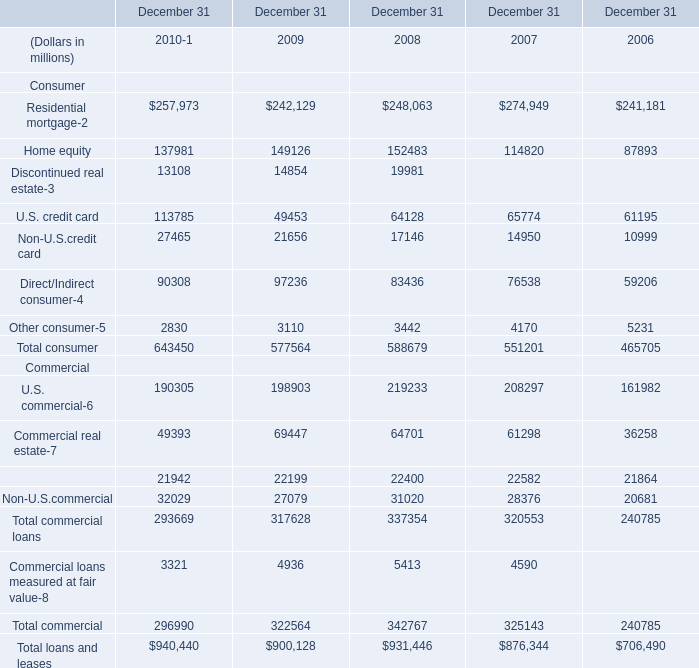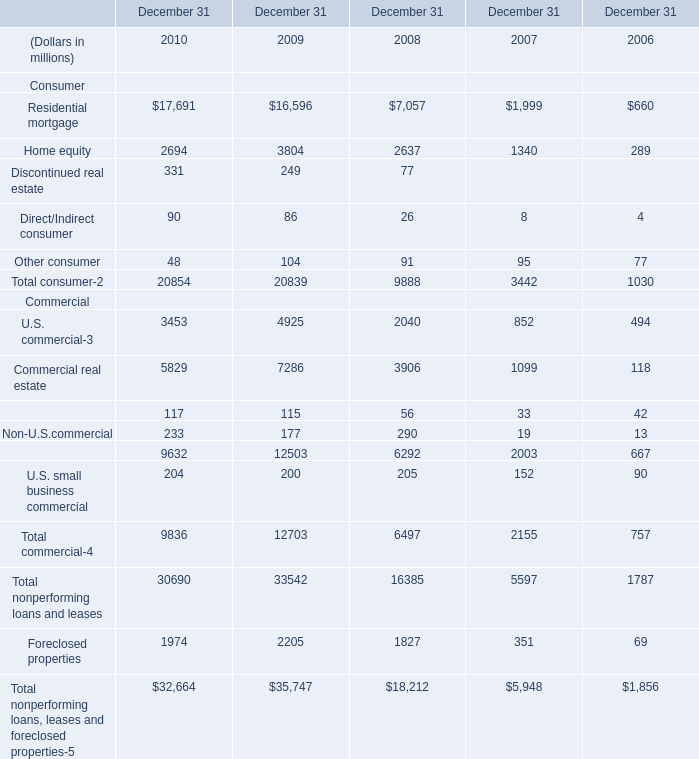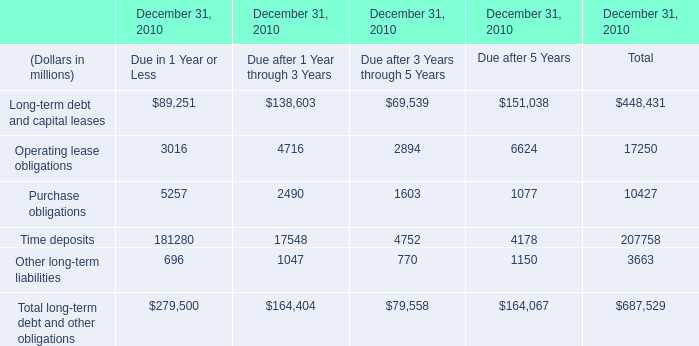What's the average of Residential mortgage of December 31 2008, and Purchase obligations of December 31, 2010 Due after 5 Years ? 
Computations: ((7057.0 + 1077.0) / 2)
Answer: 4067.0. 